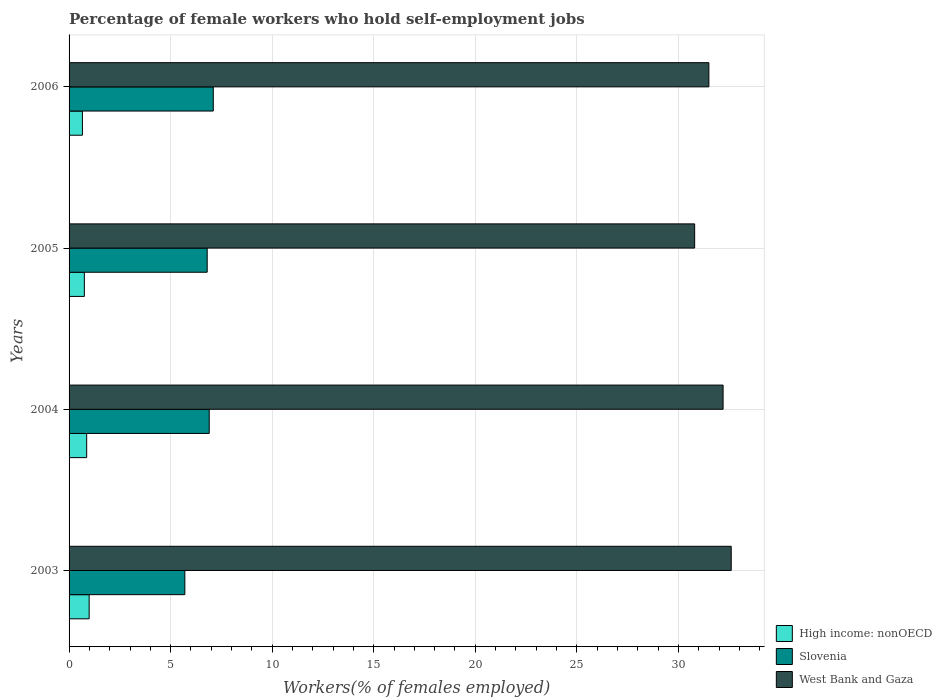Are the number of bars on each tick of the Y-axis equal?
Offer a very short reply. Yes. How many bars are there on the 1st tick from the bottom?
Your response must be concise. 3. In how many cases, is the number of bars for a given year not equal to the number of legend labels?
Offer a terse response. 0. What is the percentage of self-employed female workers in West Bank and Gaza in 2005?
Your answer should be very brief. 30.8. Across all years, what is the maximum percentage of self-employed female workers in West Bank and Gaza?
Make the answer very short. 32.6. Across all years, what is the minimum percentage of self-employed female workers in High income: nonOECD?
Provide a short and direct response. 0.66. In which year was the percentage of self-employed female workers in High income: nonOECD maximum?
Offer a very short reply. 2003. What is the total percentage of self-employed female workers in West Bank and Gaza in the graph?
Make the answer very short. 127.1. What is the difference between the percentage of self-employed female workers in Slovenia in 2003 and that in 2005?
Your answer should be very brief. -1.1. What is the difference between the percentage of self-employed female workers in West Bank and Gaza in 2004 and the percentage of self-employed female workers in High income: nonOECD in 2003?
Provide a succinct answer. 31.21. What is the average percentage of self-employed female workers in West Bank and Gaza per year?
Offer a terse response. 31.77. In the year 2006, what is the difference between the percentage of self-employed female workers in High income: nonOECD and percentage of self-employed female workers in Slovenia?
Ensure brevity in your answer.  -6.44. What is the ratio of the percentage of self-employed female workers in High income: nonOECD in 2005 to that in 2006?
Ensure brevity in your answer.  1.15. Is the percentage of self-employed female workers in West Bank and Gaza in 2005 less than that in 2006?
Your response must be concise. Yes. Is the difference between the percentage of self-employed female workers in High income: nonOECD in 2005 and 2006 greater than the difference between the percentage of self-employed female workers in Slovenia in 2005 and 2006?
Ensure brevity in your answer.  Yes. What is the difference between the highest and the second highest percentage of self-employed female workers in High income: nonOECD?
Your answer should be very brief. 0.12. What is the difference between the highest and the lowest percentage of self-employed female workers in Slovenia?
Give a very brief answer. 1.4. In how many years, is the percentage of self-employed female workers in Slovenia greater than the average percentage of self-employed female workers in Slovenia taken over all years?
Offer a very short reply. 3. What does the 2nd bar from the top in 2003 represents?
Make the answer very short. Slovenia. What does the 1st bar from the bottom in 2003 represents?
Give a very brief answer. High income: nonOECD. How many bars are there?
Give a very brief answer. 12. How many years are there in the graph?
Ensure brevity in your answer.  4. What is the difference between two consecutive major ticks on the X-axis?
Give a very brief answer. 5. How many legend labels are there?
Ensure brevity in your answer.  3. How are the legend labels stacked?
Your answer should be very brief. Vertical. What is the title of the graph?
Make the answer very short. Percentage of female workers who hold self-employment jobs. What is the label or title of the X-axis?
Your response must be concise. Workers(% of females employed). What is the label or title of the Y-axis?
Keep it short and to the point. Years. What is the Workers(% of females employed) of High income: nonOECD in 2003?
Offer a terse response. 0.99. What is the Workers(% of females employed) in Slovenia in 2003?
Your response must be concise. 5.7. What is the Workers(% of females employed) of West Bank and Gaza in 2003?
Ensure brevity in your answer.  32.6. What is the Workers(% of females employed) of High income: nonOECD in 2004?
Provide a short and direct response. 0.87. What is the Workers(% of females employed) in Slovenia in 2004?
Your response must be concise. 6.9. What is the Workers(% of females employed) of West Bank and Gaza in 2004?
Offer a terse response. 32.2. What is the Workers(% of females employed) of High income: nonOECD in 2005?
Your response must be concise. 0.75. What is the Workers(% of females employed) of Slovenia in 2005?
Your response must be concise. 6.8. What is the Workers(% of females employed) of West Bank and Gaza in 2005?
Keep it short and to the point. 30.8. What is the Workers(% of females employed) of High income: nonOECD in 2006?
Your answer should be compact. 0.66. What is the Workers(% of females employed) of Slovenia in 2006?
Ensure brevity in your answer.  7.1. What is the Workers(% of females employed) of West Bank and Gaza in 2006?
Your answer should be very brief. 31.5. Across all years, what is the maximum Workers(% of females employed) of High income: nonOECD?
Give a very brief answer. 0.99. Across all years, what is the maximum Workers(% of females employed) of Slovenia?
Keep it short and to the point. 7.1. Across all years, what is the maximum Workers(% of females employed) of West Bank and Gaza?
Make the answer very short. 32.6. Across all years, what is the minimum Workers(% of females employed) of High income: nonOECD?
Ensure brevity in your answer.  0.66. Across all years, what is the minimum Workers(% of females employed) of Slovenia?
Provide a short and direct response. 5.7. Across all years, what is the minimum Workers(% of females employed) of West Bank and Gaza?
Keep it short and to the point. 30.8. What is the total Workers(% of females employed) in High income: nonOECD in the graph?
Keep it short and to the point. 3.26. What is the total Workers(% of females employed) of West Bank and Gaza in the graph?
Give a very brief answer. 127.1. What is the difference between the Workers(% of females employed) of High income: nonOECD in 2003 and that in 2004?
Offer a terse response. 0.12. What is the difference between the Workers(% of females employed) of West Bank and Gaza in 2003 and that in 2004?
Offer a very short reply. 0.4. What is the difference between the Workers(% of females employed) in High income: nonOECD in 2003 and that in 2005?
Give a very brief answer. 0.24. What is the difference between the Workers(% of females employed) of Slovenia in 2003 and that in 2005?
Ensure brevity in your answer.  -1.1. What is the difference between the Workers(% of females employed) of West Bank and Gaza in 2003 and that in 2005?
Your answer should be compact. 1.8. What is the difference between the Workers(% of females employed) in High income: nonOECD in 2003 and that in 2006?
Make the answer very short. 0.33. What is the difference between the Workers(% of females employed) of Slovenia in 2003 and that in 2006?
Provide a succinct answer. -1.4. What is the difference between the Workers(% of females employed) in High income: nonOECD in 2004 and that in 2005?
Your response must be concise. 0.11. What is the difference between the Workers(% of females employed) of Slovenia in 2004 and that in 2005?
Provide a short and direct response. 0.1. What is the difference between the Workers(% of females employed) in High income: nonOECD in 2004 and that in 2006?
Provide a succinct answer. 0.21. What is the difference between the Workers(% of females employed) in Slovenia in 2004 and that in 2006?
Give a very brief answer. -0.2. What is the difference between the Workers(% of females employed) in High income: nonOECD in 2005 and that in 2006?
Your answer should be very brief. 0.1. What is the difference between the Workers(% of females employed) of Slovenia in 2005 and that in 2006?
Your answer should be very brief. -0.3. What is the difference between the Workers(% of females employed) of High income: nonOECD in 2003 and the Workers(% of females employed) of Slovenia in 2004?
Make the answer very short. -5.91. What is the difference between the Workers(% of females employed) of High income: nonOECD in 2003 and the Workers(% of females employed) of West Bank and Gaza in 2004?
Your response must be concise. -31.21. What is the difference between the Workers(% of females employed) of Slovenia in 2003 and the Workers(% of females employed) of West Bank and Gaza in 2004?
Your answer should be compact. -26.5. What is the difference between the Workers(% of females employed) of High income: nonOECD in 2003 and the Workers(% of females employed) of Slovenia in 2005?
Your answer should be very brief. -5.81. What is the difference between the Workers(% of females employed) of High income: nonOECD in 2003 and the Workers(% of females employed) of West Bank and Gaza in 2005?
Offer a very short reply. -29.81. What is the difference between the Workers(% of females employed) of Slovenia in 2003 and the Workers(% of females employed) of West Bank and Gaza in 2005?
Provide a succinct answer. -25.1. What is the difference between the Workers(% of females employed) in High income: nonOECD in 2003 and the Workers(% of females employed) in Slovenia in 2006?
Offer a terse response. -6.11. What is the difference between the Workers(% of females employed) of High income: nonOECD in 2003 and the Workers(% of females employed) of West Bank and Gaza in 2006?
Keep it short and to the point. -30.51. What is the difference between the Workers(% of females employed) of Slovenia in 2003 and the Workers(% of females employed) of West Bank and Gaza in 2006?
Your answer should be compact. -25.8. What is the difference between the Workers(% of females employed) in High income: nonOECD in 2004 and the Workers(% of females employed) in Slovenia in 2005?
Your response must be concise. -5.93. What is the difference between the Workers(% of females employed) in High income: nonOECD in 2004 and the Workers(% of females employed) in West Bank and Gaza in 2005?
Ensure brevity in your answer.  -29.93. What is the difference between the Workers(% of females employed) of Slovenia in 2004 and the Workers(% of females employed) of West Bank and Gaza in 2005?
Keep it short and to the point. -23.9. What is the difference between the Workers(% of females employed) in High income: nonOECD in 2004 and the Workers(% of females employed) in Slovenia in 2006?
Give a very brief answer. -6.23. What is the difference between the Workers(% of females employed) in High income: nonOECD in 2004 and the Workers(% of females employed) in West Bank and Gaza in 2006?
Give a very brief answer. -30.63. What is the difference between the Workers(% of females employed) of Slovenia in 2004 and the Workers(% of females employed) of West Bank and Gaza in 2006?
Your answer should be compact. -24.6. What is the difference between the Workers(% of females employed) of High income: nonOECD in 2005 and the Workers(% of females employed) of Slovenia in 2006?
Make the answer very short. -6.35. What is the difference between the Workers(% of females employed) in High income: nonOECD in 2005 and the Workers(% of females employed) in West Bank and Gaza in 2006?
Make the answer very short. -30.75. What is the difference between the Workers(% of females employed) of Slovenia in 2005 and the Workers(% of females employed) of West Bank and Gaza in 2006?
Your answer should be compact. -24.7. What is the average Workers(% of females employed) in High income: nonOECD per year?
Give a very brief answer. 0.82. What is the average Workers(% of females employed) of Slovenia per year?
Your answer should be very brief. 6.62. What is the average Workers(% of females employed) in West Bank and Gaza per year?
Offer a very short reply. 31.77. In the year 2003, what is the difference between the Workers(% of females employed) in High income: nonOECD and Workers(% of females employed) in Slovenia?
Ensure brevity in your answer.  -4.71. In the year 2003, what is the difference between the Workers(% of females employed) in High income: nonOECD and Workers(% of females employed) in West Bank and Gaza?
Provide a short and direct response. -31.61. In the year 2003, what is the difference between the Workers(% of females employed) of Slovenia and Workers(% of females employed) of West Bank and Gaza?
Provide a short and direct response. -26.9. In the year 2004, what is the difference between the Workers(% of females employed) of High income: nonOECD and Workers(% of females employed) of Slovenia?
Offer a terse response. -6.03. In the year 2004, what is the difference between the Workers(% of females employed) of High income: nonOECD and Workers(% of females employed) of West Bank and Gaza?
Provide a succinct answer. -31.33. In the year 2004, what is the difference between the Workers(% of females employed) in Slovenia and Workers(% of females employed) in West Bank and Gaza?
Provide a short and direct response. -25.3. In the year 2005, what is the difference between the Workers(% of females employed) of High income: nonOECD and Workers(% of females employed) of Slovenia?
Your answer should be compact. -6.05. In the year 2005, what is the difference between the Workers(% of females employed) in High income: nonOECD and Workers(% of females employed) in West Bank and Gaza?
Make the answer very short. -30.05. In the year 2005, what is the difference between the Workers(% of females employed) in Slovenia and Workers(% of females employed) in West Bank and Gaza?
Provide a short and direct response. -24. In the year 2006, what is the difference between the Workers(% of females employed) of High income: nonOECD and Workers(% of females employed) of Slovenia?
Offer a very short reply. -6.44. In the year 2006, what is the difference between the Workers(% of females employed) of High income: nonOECD and Workers(% of females employed) of West Bank and Gaza?
Provide a succinct answer. -30.84. In the year 2006, what is the difference between the Workers(% of females employed) of Slovenia and Workers(% of females employed) of West Bank and Gaza?
Provide a succinct answer. -24.4. What is the ratio of the Workers(% of females employed) in High income: nonOECD in 2003 to that in 2004?
Offer a very short reply. 1.14. What is the ratio of the Workers(% of females employed) of Slovenia in 2003 to that in 2004?
Offer a very short reply. 0.83. What is the ratio of the Workers(% of females employed) of West Bank and Gaza in 2003 to that in 2004?
Offer a terse response. 1.01. What is the ratio of the Workers(% of females employed) in High income: nonOECD in 2003 to that in 2005?
Ensure brevity in your answer.  1.31. What is the ratio of the Workers(% of females employed) of Slovenia in 2003 to that in 2005?
Make the answer very short. 0.84. What is the ratio of the Workers(% of females employed) in West Bank and Gaza in 2003 to that in 2005?
Give a very brief answer. 1.06. What is the ratio of the Workers(% of females employed) in High income: nonOECD in 2003 to that in 2006?
Give a very brief answer. 1.5. What is the ratio of the Workers(% of females employed) of Slovenia in 2003 to that in 2006?
Make the answer very short. 0.8. What is the ratio of the Workers(% of females employed) of West Bank and Gaza in 2003 to that in 2006?
Ensure brevity in your answer.  1.03. What is the ratio of the Workers(% of females employed) of High income: nonOECD in 2004 to that in 2005?
Keep it short and to the point. 1.15. What is the ratio of the Workers(% of females employed) in Slovenia in 2004 to that in 2005?
Make the answer very short. 1.01. What is the ratio of the Workers(% of females employed) in West Bank and Gaza in 2004 to that in 2005?
Your answer should be very brief. 1.05. What is the ratio of the Workers(% of females employed) in High income: nonOECD in 2004 to that in 2006?
Offer a terse response. 1.32. What is the ratio of the Workers(% of females employed) in Slovenia in 2004 to that in 2006?
Offer a very short reply. 0.97. What is the ratio of the Workers(% of females employed) in West Bank and Gaza in 2004 to that in 2006?
Your answer should be very brief. 1.02. What is the ratio of the Workers(% of females employed) of High income: nonOECD in 2005 to that in 2006?
Your answer should be very brief. 1.15. What is the ratio of the Workers(% of females employed) in Slovenia in 2005 to that in 2006?
Make the answer very short. 0.96. What is the ratio of the Workers(% of females employed) of West Bank and Gaza in 2005 to that in 2006?
Offer a very short reply. 0.98. What is the difference between the highest and the second highest Workers(% of females employed) of High income: nonOECD?
Provide a succinct answer. 0.12. What is the difference between the highest and the second highest Workers(% of females employed) of West Bank and Gaza?
Your answer should be very brief. 0.4. What is the difference between the highest and the lowest Workers(% of females employed) in High income: nonOECD?
Provide a short and direct response. 0.33. 